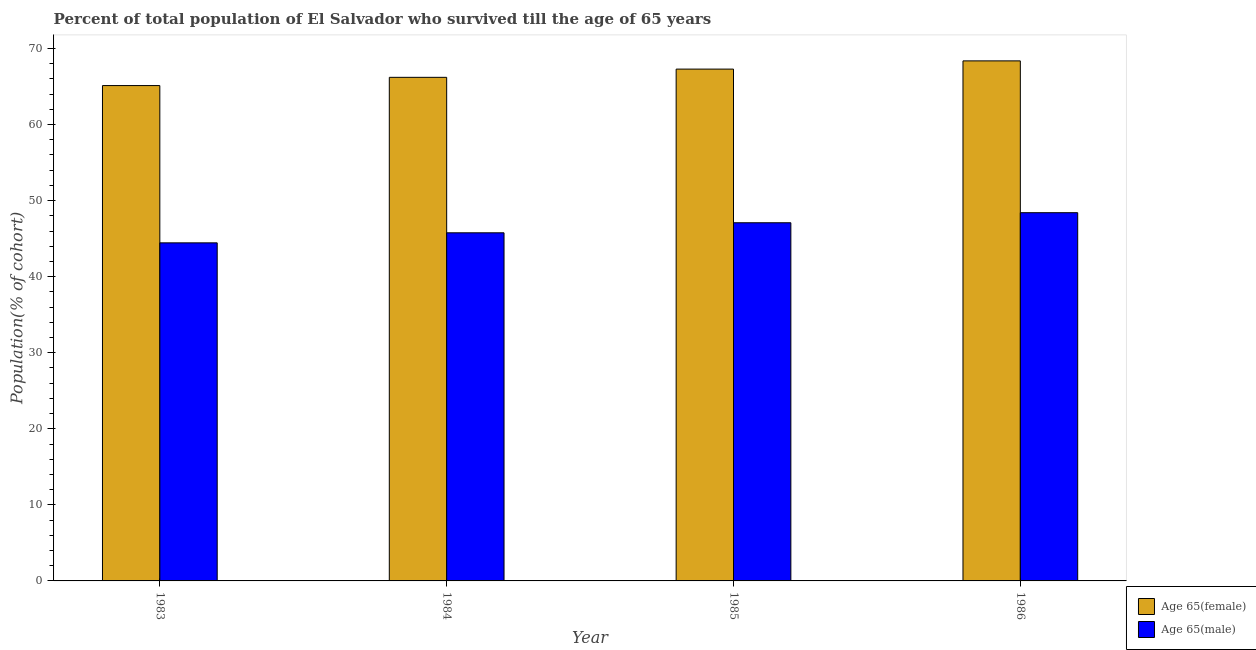How many different coloured bars are there?
Your answer should be compact. 2. Are the number of bars per tick equal to the number of legend labels?
Ensure brevity in your answer.  Yes. Are the number of bars on each tick of the X-axis equal?
Provide a short and direct response. Yes. How many bars are there on the 3rd tick from the left?
Ensure brevity in your answer.  2. What is the label of the 4th group of bars from the left?
Your answer should be very brief. 1986. In how many cases, is the number of bars for a given year not equal to the number of legend labels?
Your answer should be compact. 0. What is the percentage of female population who survived till age of 65 in 1985?
Make the answer very short. 67.29. Across all years, what is the maximum percentage of female population who survived till age of 65?
Provide a short and direct response. 68.37. Across all years, what is the minimum percentage of female population who survived till age of 65?
Provide a short and direct response. 65.13. In which year was the percentage of female population who survived till age of 65 maximum?
Provide a short and direct response. 1986. In which year was the percentage of male population who survived till age of 65 minimum?
Your answer should be compact. 1983. What is the total percentage of male population who survived till age of 65 in the graph?
Your response must be concise. 185.72. What is the difference between the percentage of male population who survived till age of 65 in 1983 and that in 1984?
Offer a terse response. -1.32. What is the difference between the percentage of female population who survived till age of 65 in 1984 and the percentage of male population who survived till age of 65 in 1983?
Your answer should be very brief. 1.08. What is the average percentage of male population who survived till age of 65 per year?
Your response must be concise. 46.43. In the year 1984, what is the difference between the percentage of female population who survived till age of 65 and percentage of male population who survived till age of 65?
Your answer should be compact. 0. In how many years, is the percentage of male population who survived till age of 65 greater than 26 %?
Make the answer very short. 4. What is the ratio of the percentage of female population who survived till age of 65 in 1984 to that in 1986?
Ensure brevity in your answer.  0.97. Is the percentage of female population who survived till age of 65 in 1983 less than that in 1984?
Offer a terse response. Yes. What is the difference between the highest and the second highest percentage of female population who survived till age of 65?
Your response must be concise. 1.08. What is the difference between the highest and the lowest percentage of male population who survived till age of 65?
Provide a short and direct response. 3.96. In how many years, is the percentage of female population who survived till age of 65 greater than the average percentage of female population who survived till age of 65 taken over all years?
Offer a very short reply. 2. Is the sum of the percentage of female population who survived till age of 65 in 1983 and 1986 greater than the maximum percentage of male population who survived till age of 65 across all years?
Ensure brevity in your answer.  Yes. What does the 1st bar from the left in 1985 represents?
Offer a very short reply. Age 65(female). What does the 1st bar from the right in 1986 represents?
Your answer should be compact. Age 65(male). Are all the bars in the graph horizontal?
Keep it short and to the point. No. Does the graph contain any zero values?
Give a very brief answer. No. How many legend labels are there?
Offer a terse response. 2. What is the title of the graph?
Your answer should be compact. Percent of total population of El Salvador who survived till the age of 65 years. What is the label or title of the Y-axis?
Provide a short and direct response. Population(% of cohort). What is the Population(% of cohort) in Age 65(female) in 1983?
Offer a terse response. 65.13. What is the Population(% of cohort) in Age 65(male) in 1983?
Your answer should be compact. 44.45. What is the Population(% of cohort) in Age 65(female) in 1984?
Give a very brief answer. 66.21. What is the Population(% of cohort) in Age 65(male) in 1984?
Provide a succinct answer. 45.77. What is the Population(% of cohort) of Age 65(female) in 1985?
Offer a very short reply. 67.29. What is the Population(% of cohort) in Age 65(male) in 1985?
Provide a succinct answer. 47.09. What is the Population(% of cohort) of Age 65(female) in 1986?
Your answer should be compact. 68.37. What is the Population(% of cohort) in Age 65(male) in 1986?
Your response must be concise. 48.41. Across all years, what is the maximum Population(% of cohort) of Age 65(female)?
Your response must be concise. 68.37. Across all years, what is the maximum Population(% of cohort) of Age 65(male)?
Your response must be concise. 48.41. Across all years, what is the minimum Population(% of cohort) of Age 65(female)?
Offer a very short reply. 65.13. Across all years, what is the minimum Population(% of cohort) in Age 65(male)?
Ensure brevity in your answer.  44.45. What is the total Population(% of cohort) of Age 65(female) in the graph?
Ensure brevity in your answer.  267. What is the total Population(% of cohort) of Age 65(male) in the graph?
Your answer should be very brief. 185.72. What is the difference between the Population(% of cohort) in Age 65(female) in 1983 and that in 1984?
Provide a succinct answer. -1.08. What is the difference between the Population(% of cohort) in Age 65(male) in 1983 and that in 1984?
Give a very brief answer. -1.32. What is the difference between the Population(% of cohort) in Age 65(female) in 1983 and that in 1985?
Your response must be concise. -2.16. What is the difference between the Population(% of cohort) of Age 65(male) in 1983 and that in 1985?
Provide a short and direct response. -2.64. What is the difference between the Population(% of cohort) in Age 65(female) in 1983 and that in 1986?
Your response must be concise. -3.25. What is the difference between the Population(% of cohort) of Age 65(male) in 1983 and that in 1986?
Provide a succinct answer. -3.96. What is the difference between the Population(% of cohort) of Age 65(female) in 1984 and that in 1985?
Your response must be concise. -1.08. What is the difference between the Population(% of cohort) in Age 65(male) in 1984 and that in 1985?
Provide a succinct answer. -1.32. What is the difference between the Population(% of cohort) in Age 65(female) in 1984 and that in 1986?
Offer a very short reply. -2.16. What is the difference between the Population(% of cohort) of Age 65(male) in 1984 and that in 1986?
Offer a terse response. -2.64. What is the difference between the Population(% of cohort) of Age 65(female) in 1985 and that in 1986?
Provide a succinct answer. -1.08. What is the difference between the Population(% of cohort) in Age 65(male) in 1985 and that in 1986?
Your response must be concise. -1.32. What is the difference between the Population(% of cohort) in Age 65(female) in 1983 and the Population(% of cohort) in Age 65(male) in 1984?
Your answer should be very brief. 19.36. What is the difference between the Population(% of cohort) of Age 65(female) in 1983 and the Population(% of cohort) of Age 65(male) in 1985?
Provide a short and direct response. 18.04. What is the difference between the Population(% of cohort) of Age 65(female) in 1983 and the Population(% of cohort) of Age 65(male) in 1986?
Offer a terse response. 16.71. What is the difference between the Population(% of cohort) of Age 65(female) in 1984 and the Population(% of cohort) of Age 65(male) in 1985?
Offer a terse response. 19.12. What is the difference between the Population(% of cohort) in Age 65(female) in 1984 and the Population(% of cohort) in Age 65(male) in 1986?
Your answer should be compact. 17.8. What is the difference between the Population(% of cohort) in Age 65(female) in 1985 and the Population(% of cohort) in Age 65(male) in 1986?
Make the answer very short. 18.88. What is the average Population(% of cohort) of Age 65(female) per year?
Offer a terse response. 66.75. What is the average Population(% of cohort) of Age 65(male) per year?
Your answer should be compact. 46.43. In the year 1983, what is the difference between the Population(% of cohort) of Age 65(female) and Population(% of cohort) of Age 65(male)?
Your answer should be very brief. 20.68. In the year 1984, what is the difference between the Population(% of cohort) in Age 65(female) and Population(% of cohort) in Age 65(male)?
Your answer should be very brief. 20.44. In the year 1985, what is the difference between the Population(% of cohort) of Age 65(female) and Population(% of cohort) of Age 65(male)?
Provide a short and direct response. 20.2. In the year 1986, what is the difference between the Population(% of cohort) in Age 65(female) and Population(% of cohort) in Age 65(male)?
Keep it short and to the point. 19.96. What is the ratio of the Population(% of cohort) in Age 65(female) in 1983 to that in 1984?
Keep it short and to the point. 0.98. What is the ratio of the Population(% of cohort) in Age 65(male) in 1983 to that in 1984?
Provide a short and direct response. 0.97. What is the ratio of the Population(% of cohort) of Age 65(female) in 1983 to that in 1985?
Your answer should be very brief. 0.97. What is the ratio of the Population(% of cohort) of Age 65(male) in 1983 to that in 1985?
Offer a very short reply. 0.94. What is the ratio of the Population(% of cohort) in Age 65(female) in 1983 to that in 1986?
Your answer should be very brief. 0.95. What is the ratio of the Population(% of cohort) of Age 65(male) in 1983 to that in 1986?
Provide a short and direct response. 0.92. What is the ratio of the Population(% of cohort) of Age 65(female) in 1984 to that in 1985?
Your answer should be very brief. 0.98. What is the ratio of the Population(% of cohort) in Age 65(male) in 1984 to that in 1985?
Give a very brief answer. 0.97. What is the ratio of the Population(% of cohort) in Age 65(female) in 1984 to that in 1986?
Keep it short and to the point. 0.97. What is the ratio of the Population(% of cohort) of Age 65(male) in 1984 to that in 1986?
Your answer should be compact. 0.95. What is the ratio of the Population(% of cohort) of Age 65(female) in 1985 to that in 1986?
Your answer should be very brief. 0.98. What is the ratio of the Population(% of cohort) of Age 65(male) in 1985 to that in 1986?
Your answer should be very brief. 0.97. What is the difference between the highest and the second highest Population(% of cohort) of Age 65(female)?
Make the answer very short. 1.08. What is the difference between the highest and the second highest Population(% of cohort) of Age 65(male)?
Offer a very short reply. 1.32. What is the difference between the highest and the lowest Population(% of cohort) in Age 65(female)?
Offer a terse response. 3.25. What is the difference between the highest and the lowest Population(% of cohort) of Age 65(male)?
Provide a succinct answer. 3.96. 